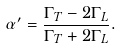Convert formula to latex. <formula><loc_0><loc_0><loc_500><loc_500>\alpha ^ { \prime } = \frac { \Gamma _ { T } - 2 \Gamma _ { L } } { \Gamma _ { T } + 2 \Gamma _ { L } } .</formula> 